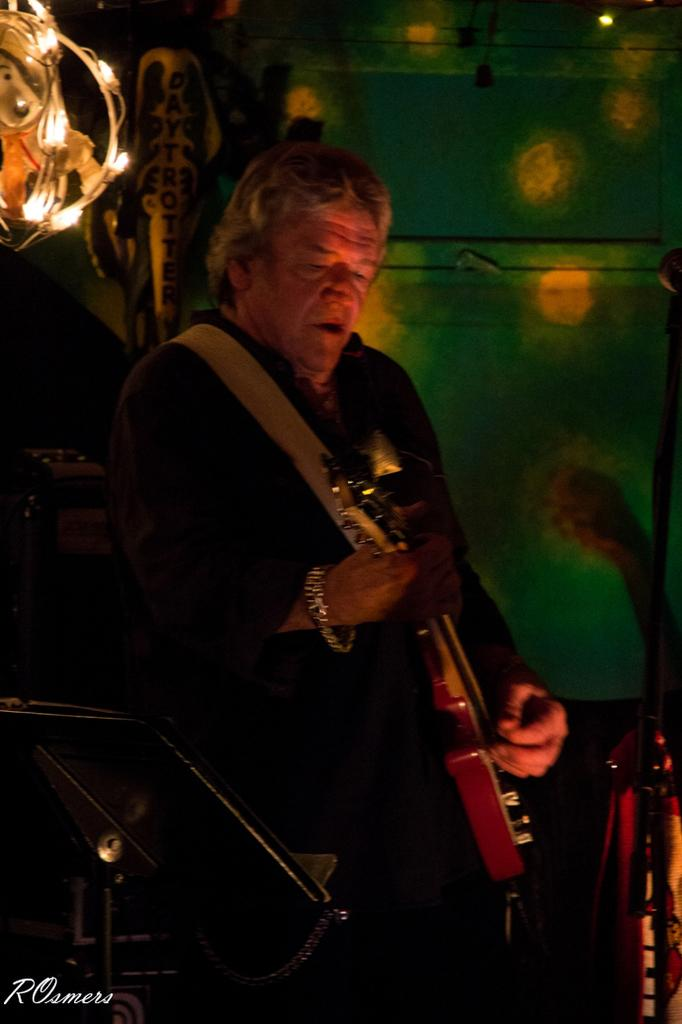What is the man in the image doing? The man is playing a guitar in the image. What can be seen in the background of the image? There are lights visible in the background of the image. What type of hill can be seen in the background of the image? There is no hill present in the image; it only features a man playing a guitar and lights in the background. 